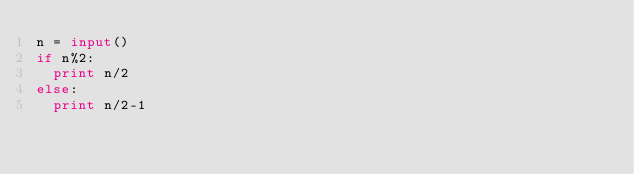<code> <loc_0><loc_0><loc_500><loc_500><_Python_>n = input()
if n%2:
  print n/2
else:
  print n/2-1</code> 